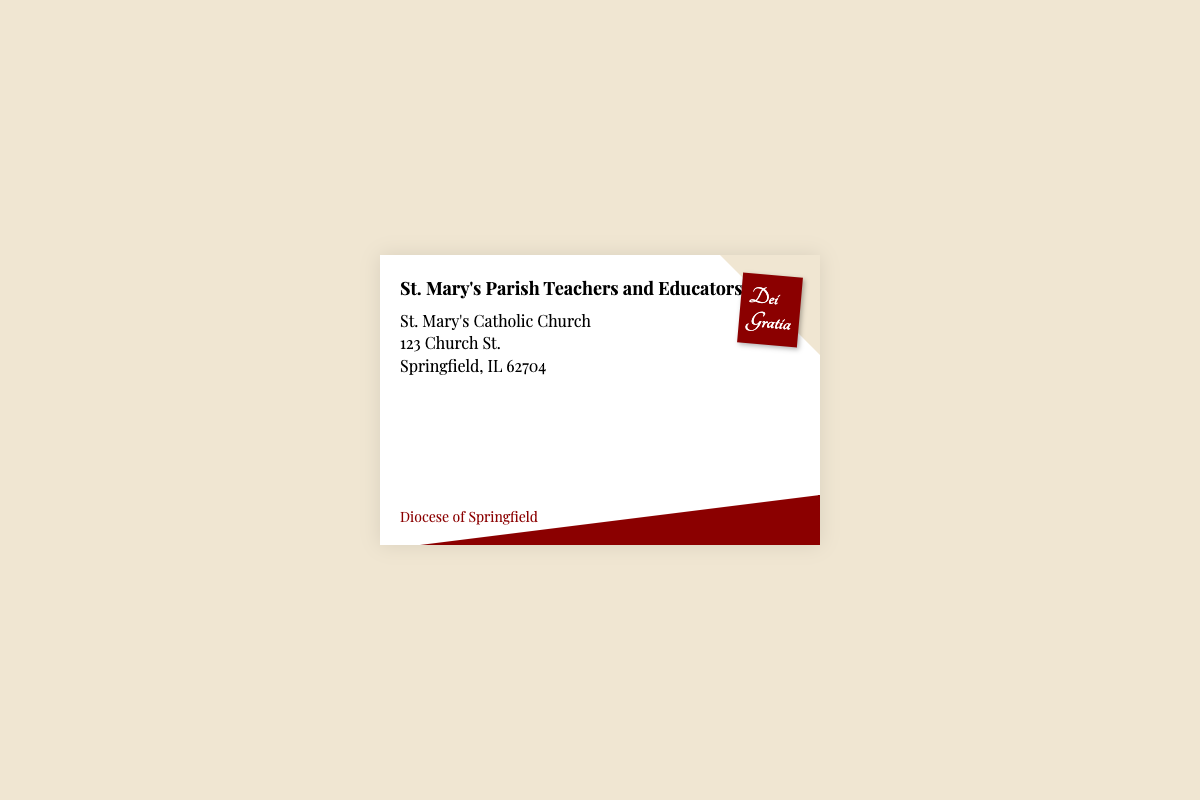what is the addressee of the letter? The addressee is the main recipient mentioned at the top of the document, which is St. Mary's Parish Teachers and Educators.
Answer: St. Mary's Parish Teachers and Educators what is the address of the addressee? The address provides specific details of where the addressee is located, including the church name, street, city, and zip code.
Answer: St. Mary's Catholic Church, 123 Church St., Springfield, IL 62704 what does "Dei Gratia" on the stamp refer to? "Dei Gratia" translates to "By the Grace of God," which is often used in religious contexts, especially in Catholicism.
Answer: By the Grace of God who is the sender of the letter? The sender is identified at the bottom of the envelope in a designated area for the sending party.
Answer: Diocese of Springfield what color is the envelope's background? The background color of the envelope is specified within the style attributes of the HTML document.
Answer: #f0e6d2 how many lines are there in the address? The address consists of multiple lines detailing different aspects of the location, specifically counted for clarity.
Answer: 3 what is the font used for the addressee? The font style employed for the addressee's text provides a distinctive appearance, making it identifiable.
Answer: Playfair Display what shapes are used for the envelope's design? Different shapes are used in the design to create visual interest and structure, especially on the corners of the envelope.
Answer: Triangles how is the stamp positioned on the envelope? The stamp's position is indicated through absolute positioning in the style, providing a specific layout reference.
Answer: Top right 